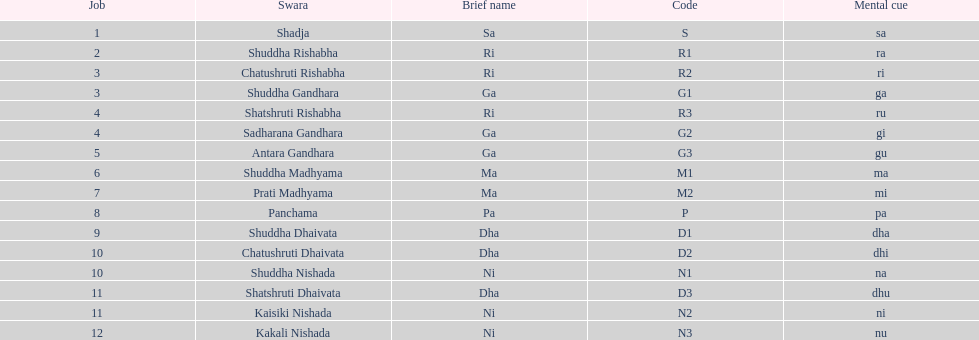What is the total number of positions listed? 16. 